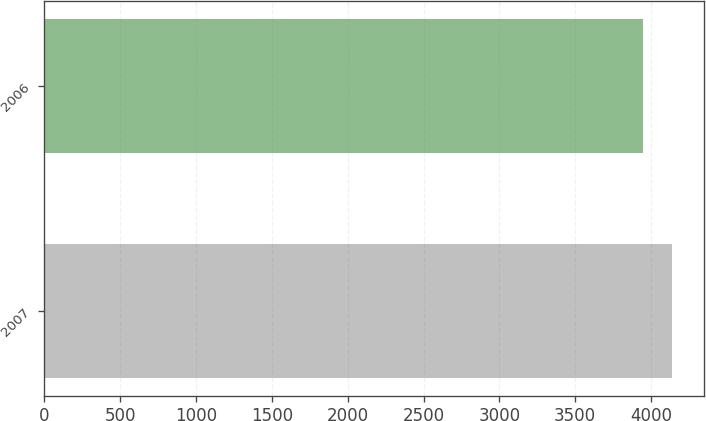Convert chart. <chart><loc_0><loc_0><loc_500><loc_500><bar_chart><fcel>2007<fcel>2006<nl><fcel>4139.2<fcel>3944.1<nl></chart> 